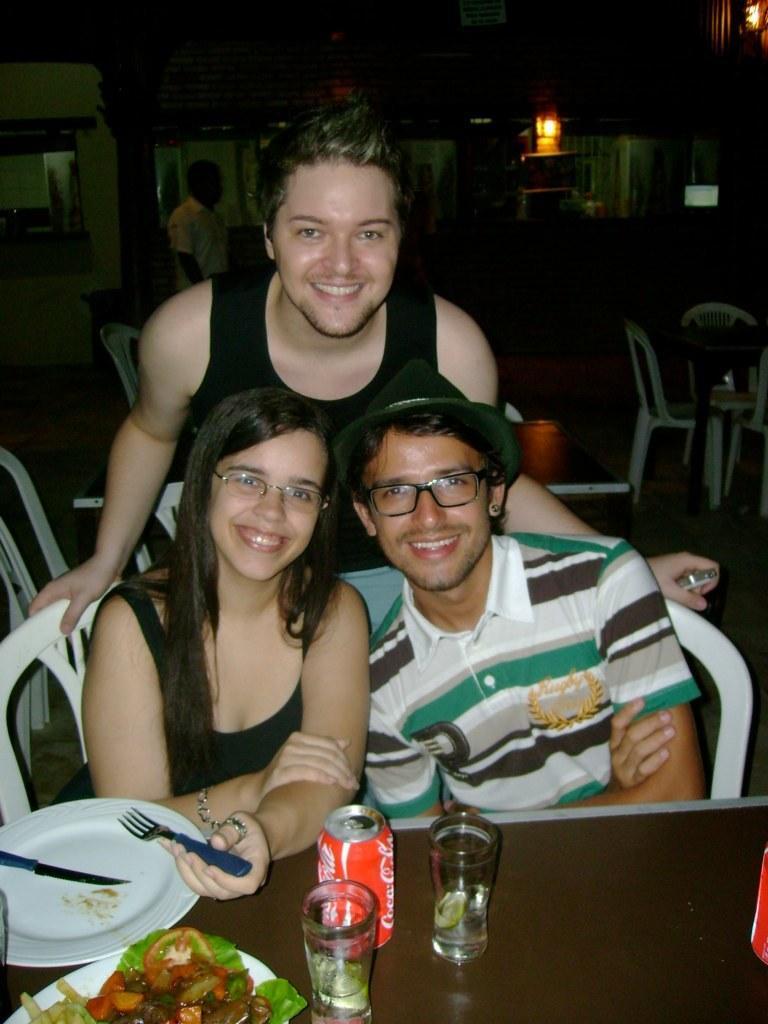Could you give a brief overview of what you see in this image? in the picture there are three persons two men and one woman sitting in chair and one man is standing in front of a table on the table there are different items. 